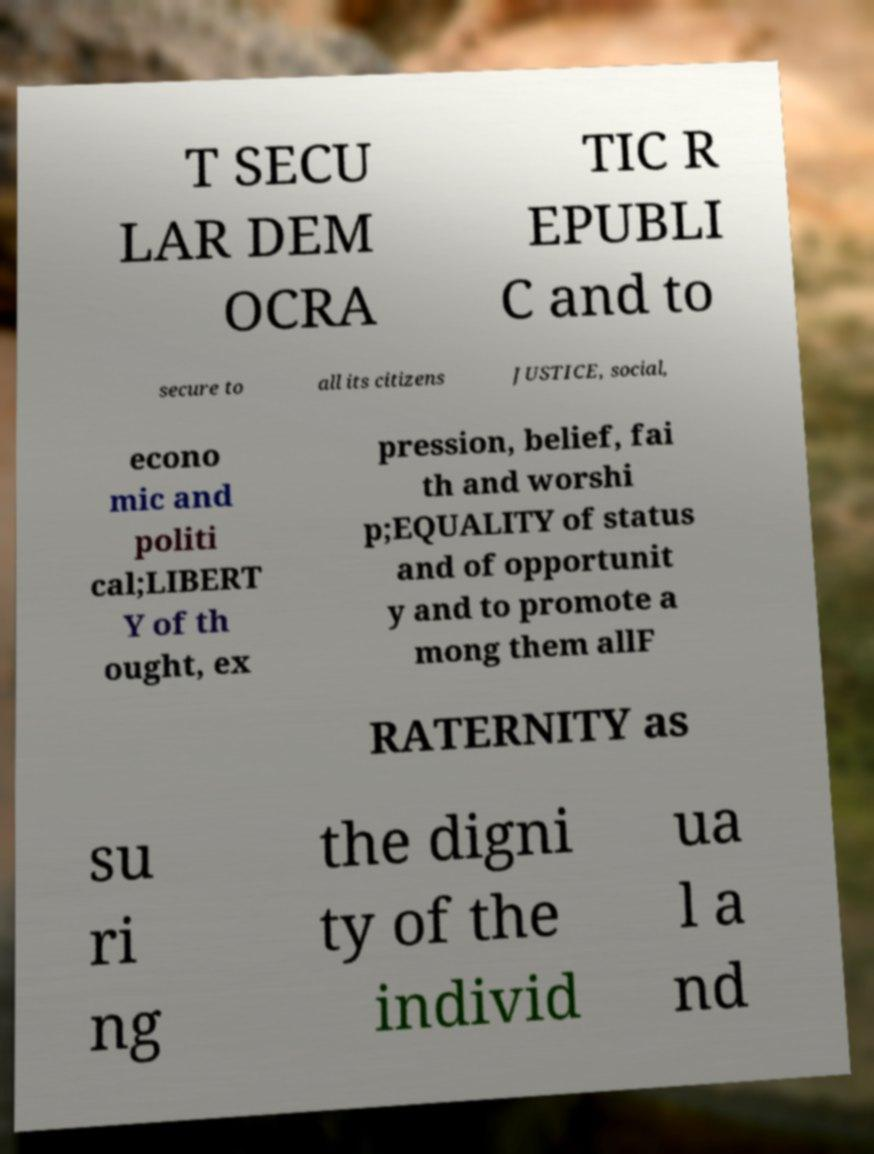What messages or text are displayed in this image? I need them in a readable, typed format. T SECU LAR DEM OCRA TIC R EPUBLI C and to secure to all its citizens JUSTICE, social, econo mic and politi cal;LIBERT Y of th ought, ex pression, belief, fai th and worshi p;EQUALITY of status and of opportunit y and to promote a mong them allF RATERNITY as su ri ng the digni ty of the individ ua l a nd 